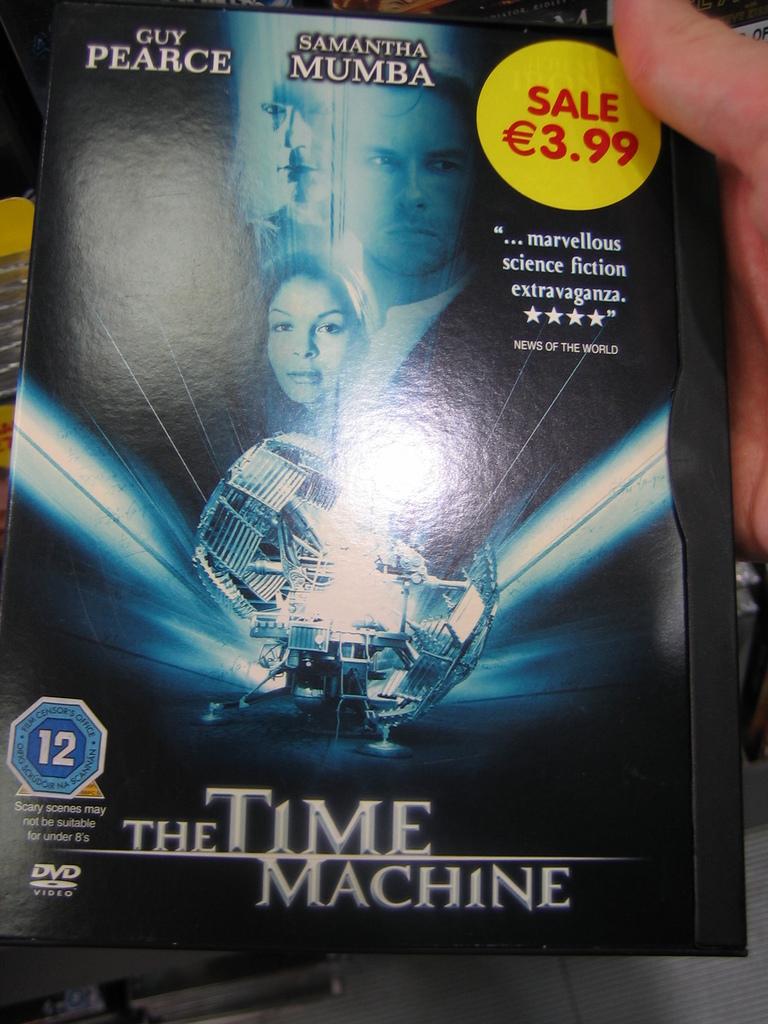What man stares in this movie?
Keep it short and to the point. Guy pearce. How expensive is this movie?
Your response must be concise. 3.99. 